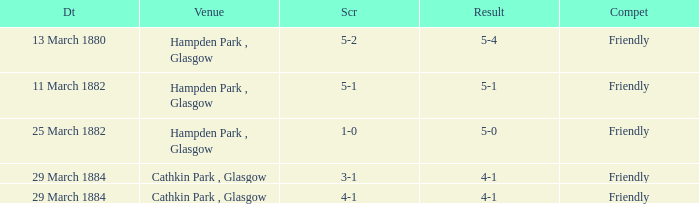Which competition had a 4-1 result, and a score of 4-1? Friendly. 